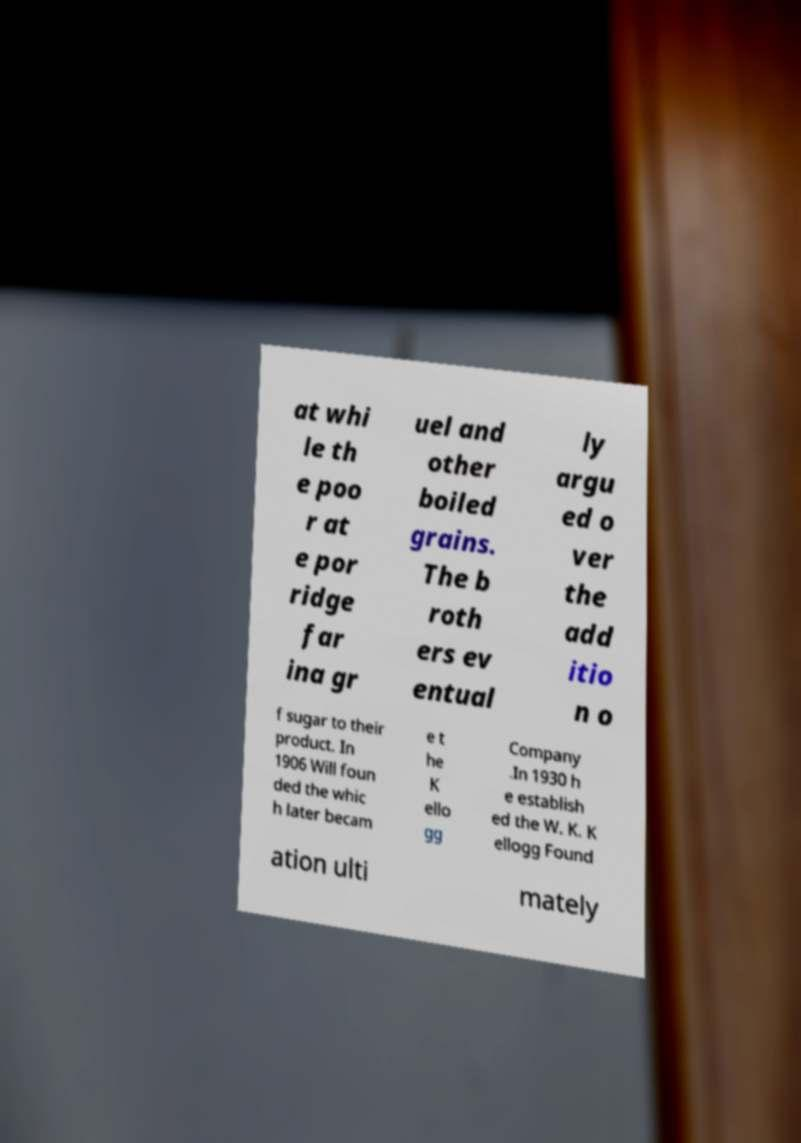Could you extract and type out the text from this image? at whi le th e poo r at e por ridge far ina gr uel and other boiled grains. The b roth ers ev entual ly argu ed o ver the add itio n o f sugar to their product. In 1906 Will foun ded the whic h later becam e t he K ello gg Company .In 1930 h e establish ed the W. K. K ellogg Found ation ulti mately 